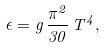<formula> <loc_0><loc_0><loc_500><loc_500>\epsilon = g \, \frac { { \pi } ^ { 2 } } { 3 0 } \, T ^ { 4 } ,</formula> 